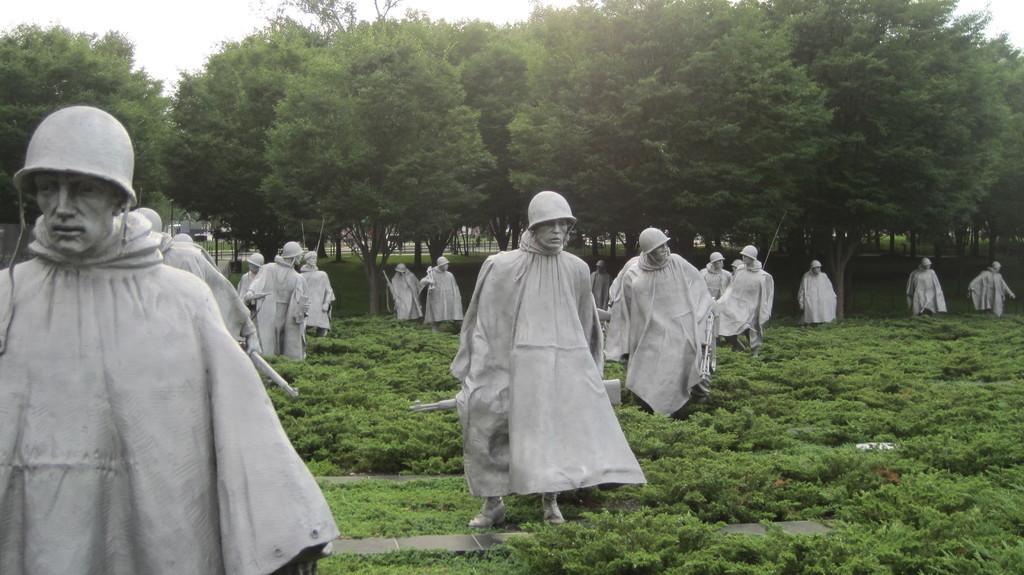Please provide a concise description of this image. In this image we can see the sculptures, grass, plants, trees, at the top we can see the sky. 